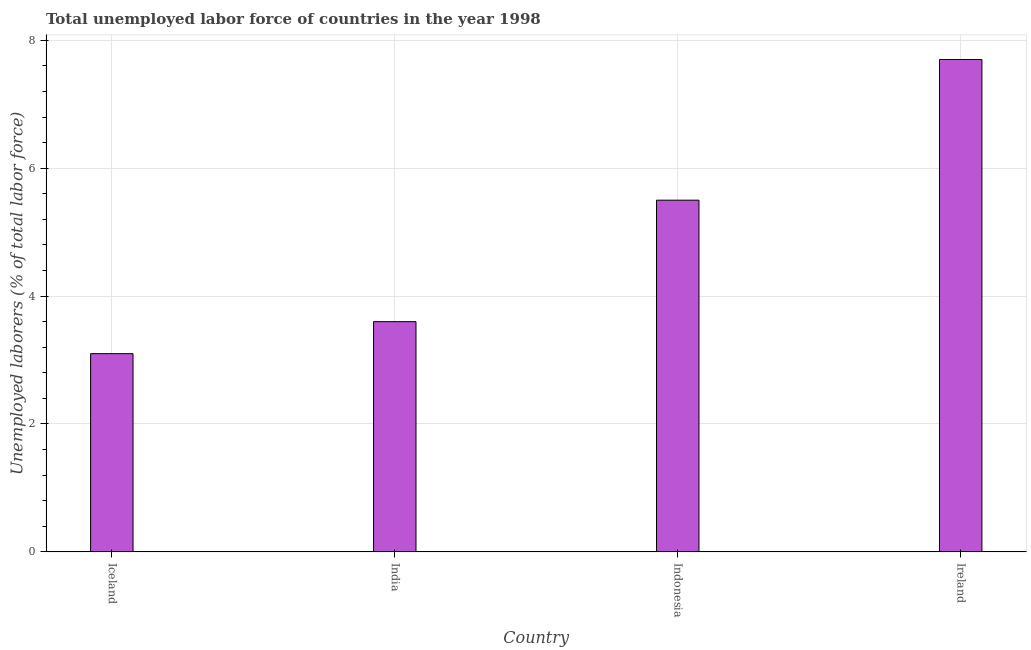Does the graph contain grids?
Your response must be concise. Yes. What is the title of the graph?
Offer a terse response. Total unemployed labor force of countries in the year 1998. What is the label or title of the X-axis?
Offer a terse response. Country. What is the label or title of the Y-axis?
Give a very brief answer. Unemployed laborers (% of total labor force). What is the total unemployed labour force in India?
Make the answer very short. 3.6. Across all countries, what is the maximum total unemployed labour force?
Ensure brevity in your answer.  7.7. Across all countries, what is the minimum total unemployed labour force?
Your response must be concise. 3.1. In which country was the total unemployed labour force maximum?
Your answer should be compact. Ireland. What is the sum of the total unemployed labour force?
Give a very brief answer. 19.9. What is the average total unemployed labour force per country?
Your answer should be very brief. 4.97. What is the median total unemployed labour force?
Your answer should be compact. 4.55. In how many countries, is the total unemployed labour force greater than 2 %?
Offer a terse response. 4. What is the ratio of the total unemployed labour force in India to that in Ireland?
Keep it short and to the point. 0.47. Is the total unemployed labour force in India less than that in Ireland?
Give a very brief answer. Yes. What is the difference between the highest and the second highest total unemployed labour force?
Provide a short and direct response. 2.2. What is the difference between the highest and the lowest total unemployed labour force?
Provide a succinct answer. 4.6. In how many countries, is the total unemployed labour force greater than the average total unemployed labour force taken over all countries?
Give a very brief answer. 2. How many bars are there?
Your answer should be compact. 4. How many countries are there in the graph?
Offer a terse response. 4. What is the Unemployed laborers (% of total labor force) in Iceland?
Offer a terse response. 3.1. What is the Unemployed laborers (% of total labor force) in India?
Your answer should be compact. 3.6. What is the Unemployed laborers (% of total labor force) of Ireland?
Your response must be concise. 7.7. What is the difference between the Unemployed laborers (% of total labor force) in Iceland and Ireland?
Offer a terse response. -4.6. What is the difference between the Unemployed laborers (% of total labor force) in India and Ireland?
Provide a short and direct response. -4.1. What is the difference between the Unemployed laborers (% of total labor force) in Indonesia and Ireland?
Offer a terse response. -2.2. What is the ratio of the Unemployed laborers (% of total labor force) in Iceland to that in India?
Offer a terse response. 0.86. What is the ratio of the Unemployed laborers (% of total labor force) in Iceland to that in Indonesia?
Your response must be concise. 0.56. What is the ratio of the Unemployed laborers (% of total labor force) in Iceland to that in Ireland?
Offer a very short reply. 0.4. What is the ratio of the Unemployed laborers (% of total labor force) in India to that in Indonesia?
Your answer should be compact. 0.66. What is the ratio of the Unemployed laborers (% of total labor force) in India to that in Ireland?
Provide a short and direct response. 0.47. What is the ratio of the Unemployed laborers (% of total labor force) in Indonesia to that in Ireland?
Your response must be concise. 0.71. 